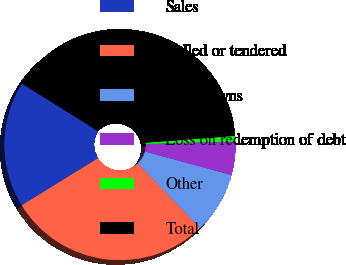<chart> <loc_0><loc_0><loc_500><loc_500><pie_chart><fcel>Sales<fcel>Called or tendered<fcel>Writedowns<fcel>Loss on redemption of debt<fcel>Other<fcel>Total<nl><fcel>17.69%<fcel>28.38%<fcel>8.59%<fcel>4.68%<fcel>0.77%<fcel>39.89%<nl></chart> 